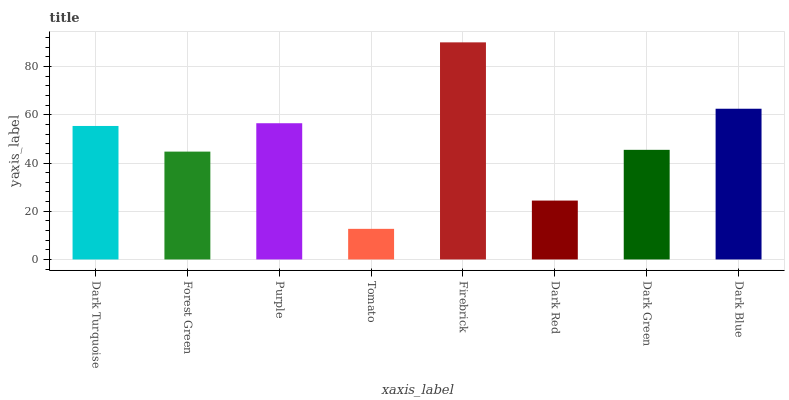Is Tomato the minimum?
Answer yes or no. Yes. Is Firebrick the maximum?
Answer yes or no. Yes. Is Forest Green the minimum?
Answer yes or no. No. Is Forest Green the maximum?
Answer yes or no. No. Is Dark Turquoise greater than Forest Green?
Answer yes or no. Yes. Is Forest Green less than Dark Turquoise?
Answer yes or no. Yes. Is Forest Green greater than Dark Turquoise?
Answer yes or no. No. Is Dark Turquoise less than Forest Green?
Answer yes or no. No. Is Dark Turquoise the high median?
Answer yes or no. Yes. Is Dark Green the low median?
Answer yes or no. Yes. Is Purple the high median?
Answer yes or no. No. Is Forest Green the low median?
Answer yes or no. No. 